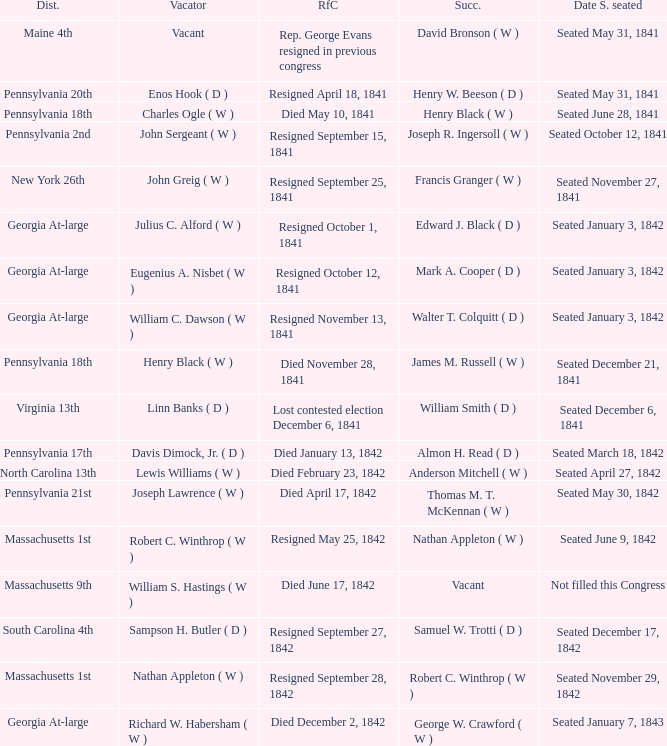Name the successor for north carolina 13th Anderson Mitchell ( W ). 